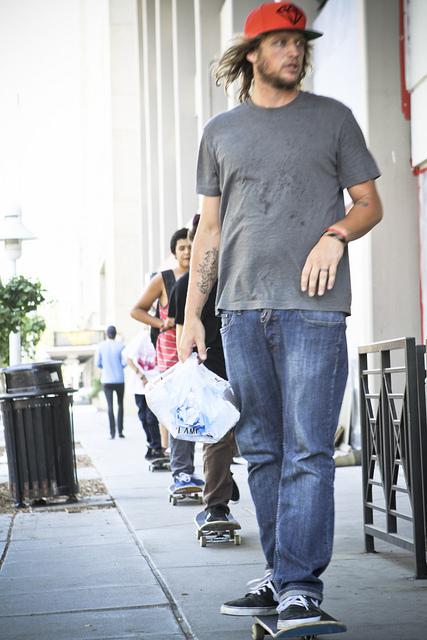Is there a place to throw away trash?
Concise answer only. Yes. How many skateboards are there?
Quick response, please. 4. What is the third person in the line have around their arm?
Answer briefly. Purse. 